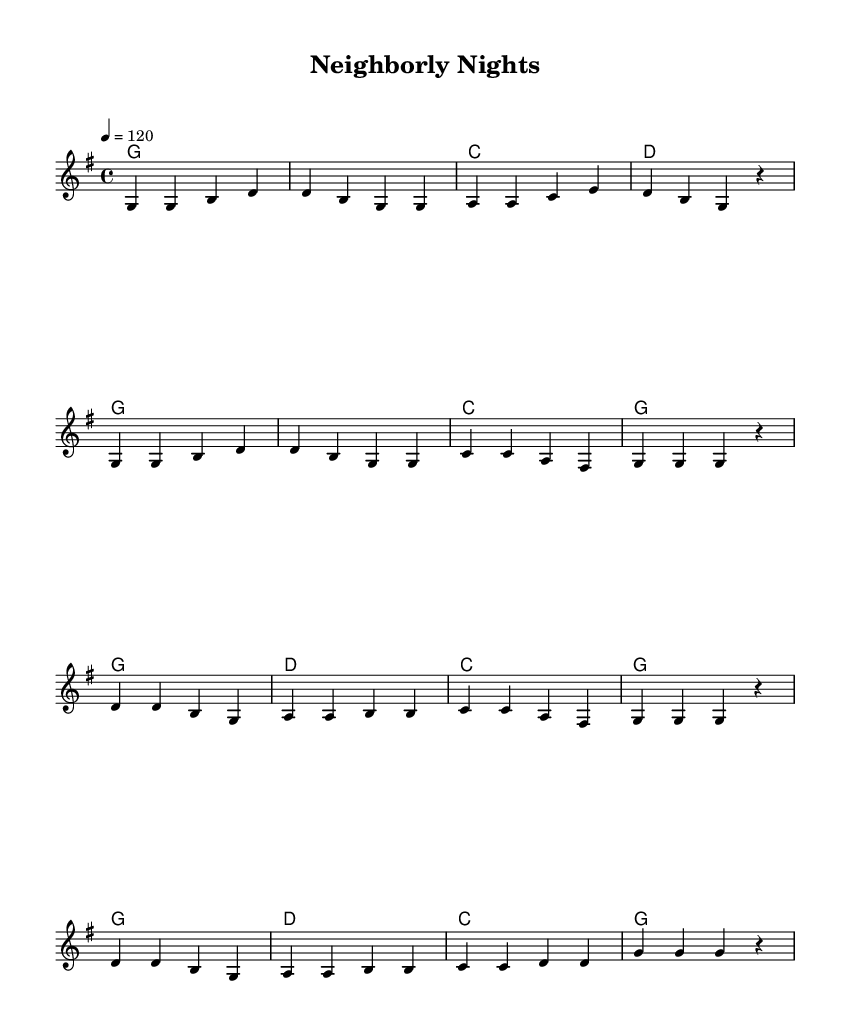What is the key signature of this music? The key signature is G major, which has one sharp (F#). This can be identified by looking at the key signature at the beginning of the staff, just after the clef sign.
Answer: G major What is the time signature of this music? The time signature is 4/4, which can be found at the beginning of the score, next to the key signature. This indicates that there are four beats in each measure and a quarter note gets one beat.
Answer: 4/4 What is the tempo marking in this music? The tempo marking is 120, indicated by the term "4 = 120". This shows that there are 120 beats per minute in a steady beat.
Answer: 120 How many measures are in the verse section? The verse consists of 8 measures, as counted in the melody section from the start of the verse to the end, including each grouping separated by the bar lines.
Answer: 8 What is the final chord in the chorus? The final chord in the chorus is G major, found at the end of the chorus section where the melody and harmonies align.
Answer: G How many times does the melody repeat in the chorus? The melody in the chorus repeats two times, as indicated by the repeated notation in the measurements of the chorus section specifically featuring the notes and chords played.
Answer: 2 What musical element emphasizes camaraderie in the lyrics? The upbeat rhythm and repetitive structures create a celebratory feel, which is a common element in country music that emphasizes friendship and camaraderie. This analysis is based on the overall style and mood conveyed through the melody and harmony.
Answer: Upbeat rhythm 